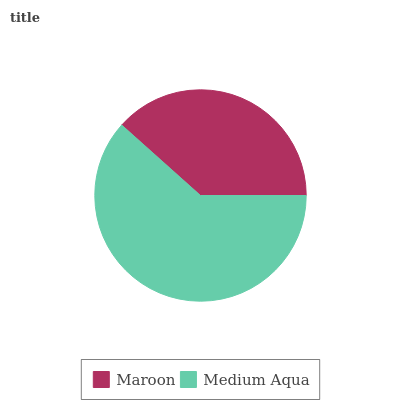Is Maroon the minimum?
Answer yes or no. Yes. Is Medium Aqua the maximum?
Answer yes or no. Yes. Is Medium Aqua the minimum?
Answer yes or no. No. Is Medium Aqua greater than Maroon?
Answer yes or no. Yes. Is Maroon less than Medium Aqua?
Answer yes or no. Yes. Is Maroon greater than Medium Aqua?
Answer yes or no. No. Is Medium Aqua less than Maroon?
Answer yes or no. No. Is Medium Aqua the high median?
Answer yes or no. Yes. Is Maroon the low median?
Answer yes or no. Yes. Is Maroon the high median?
Answer yes or no. No. Is Medium Aqua the low median?
Answer yes or no. No. 